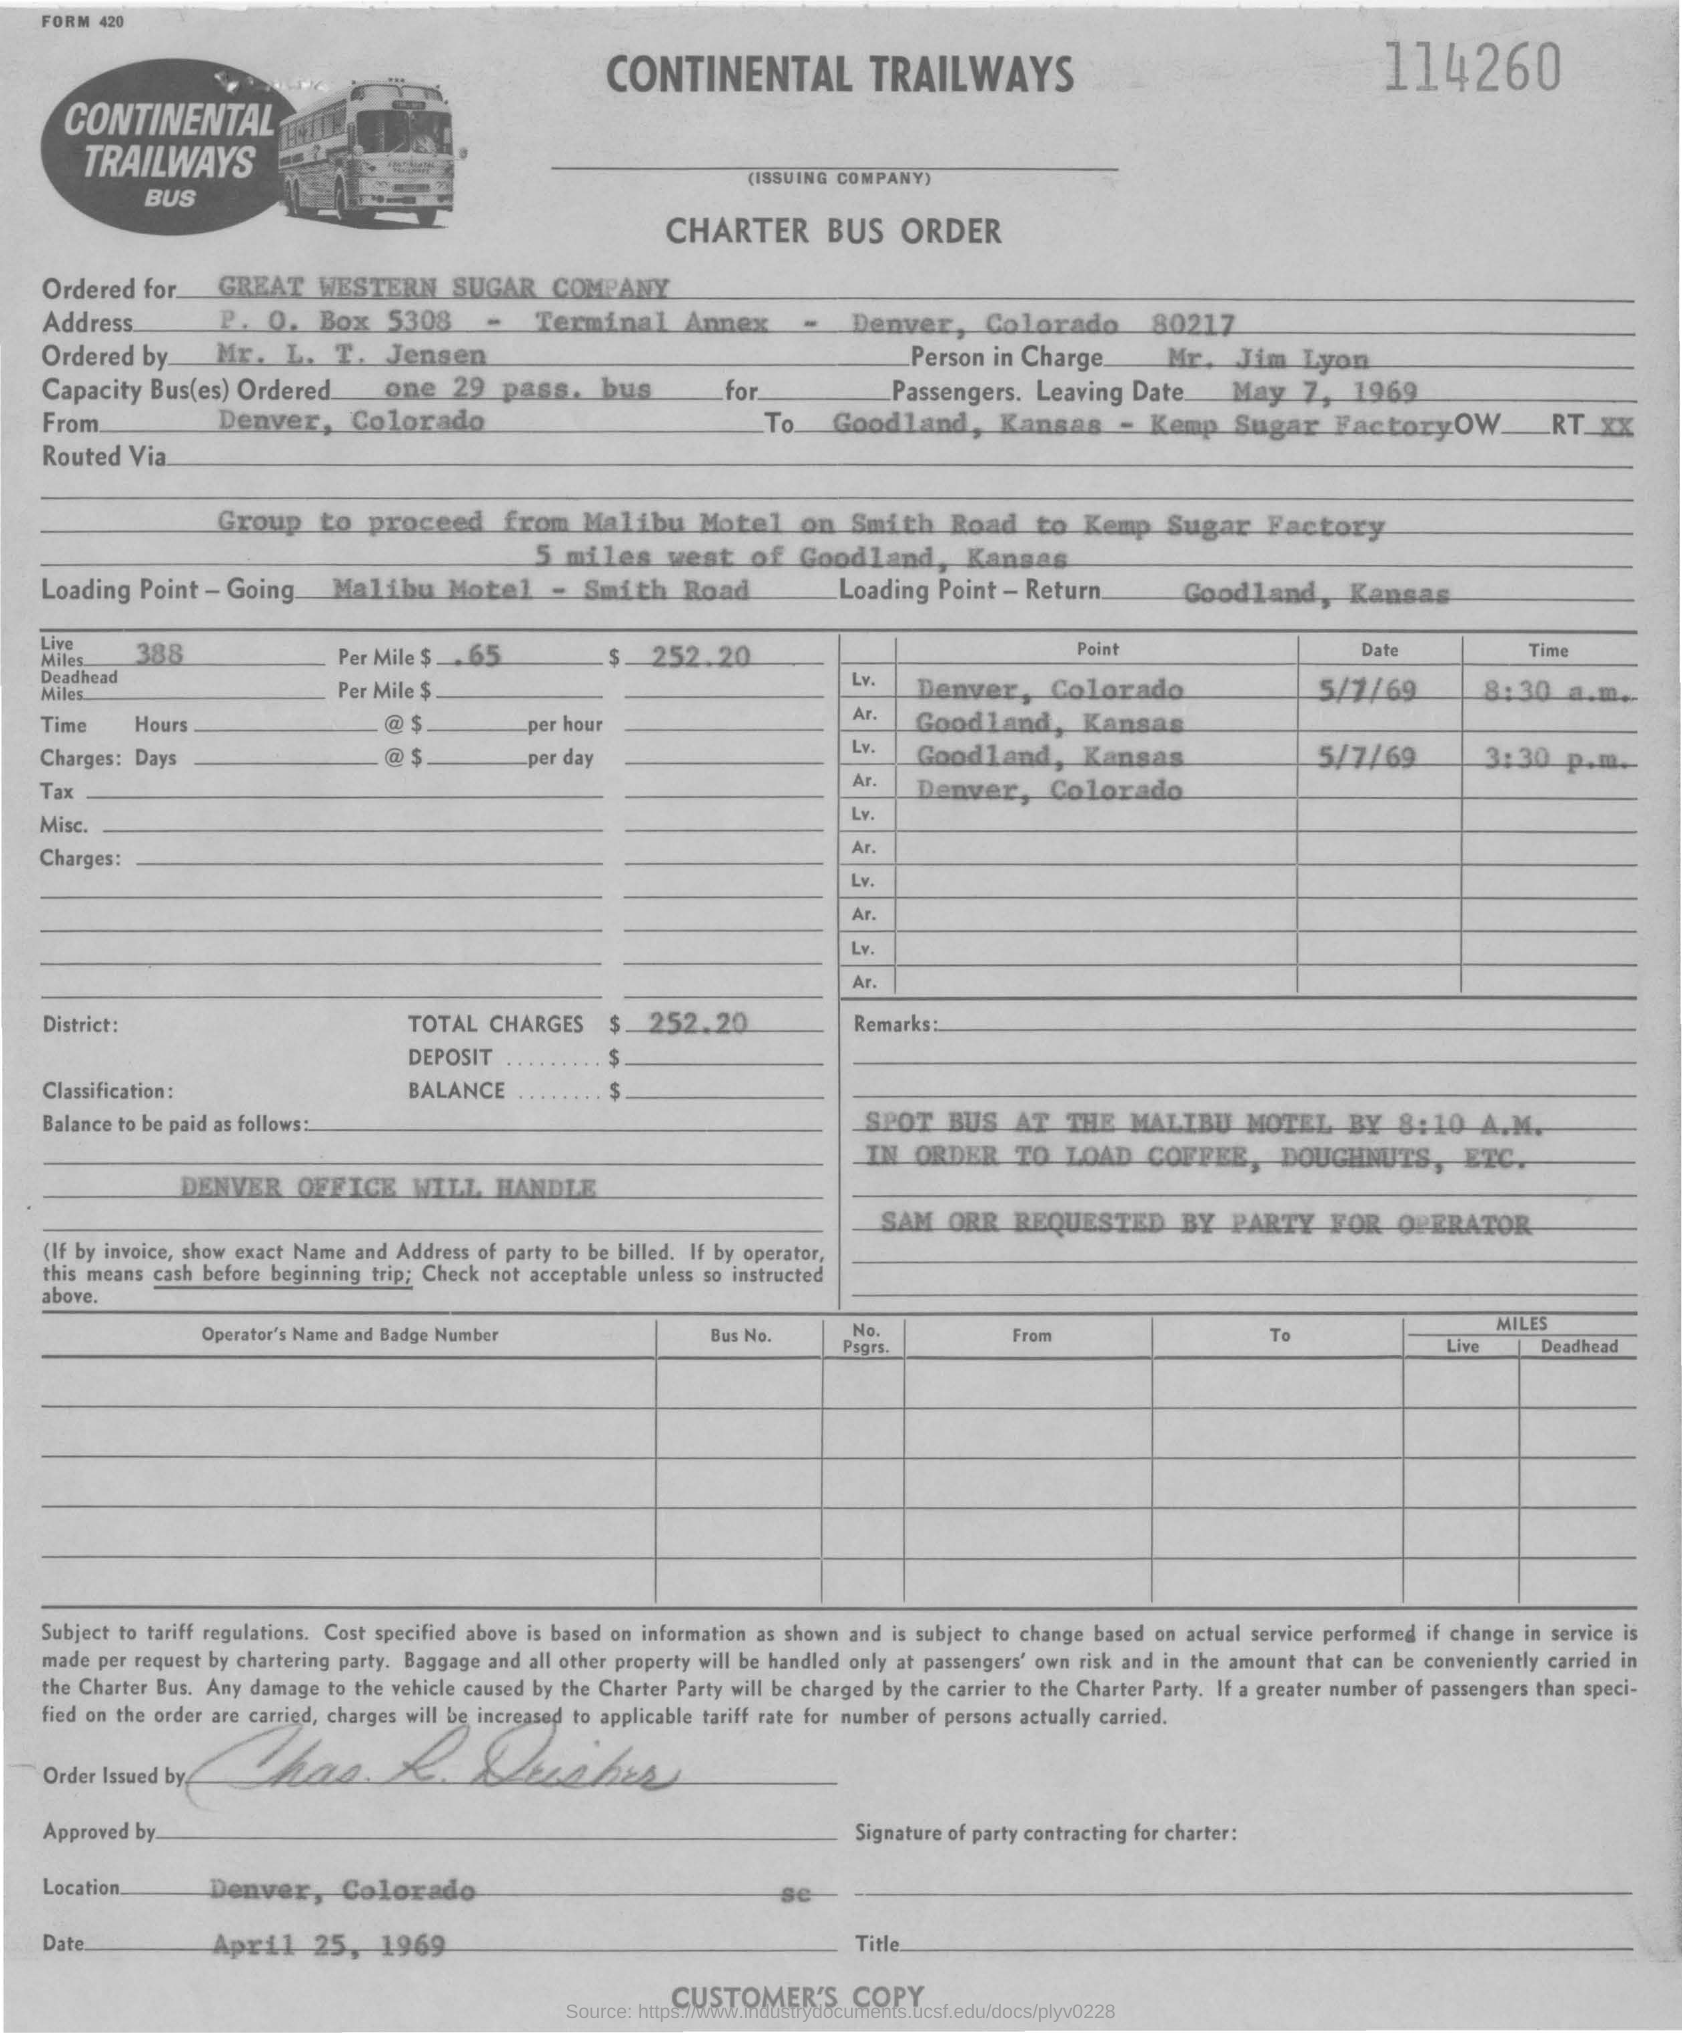List a handful of essential elements in this visual. What is a 29-passenger bus? The destination of the bus is Goodland, Kansas, where it will arrive at the Kemp Sugar Factory. The loading point in Goodland, Kansas is... The charge for the bus per mile is $0.65. The bus started in Denver, Colorado. 